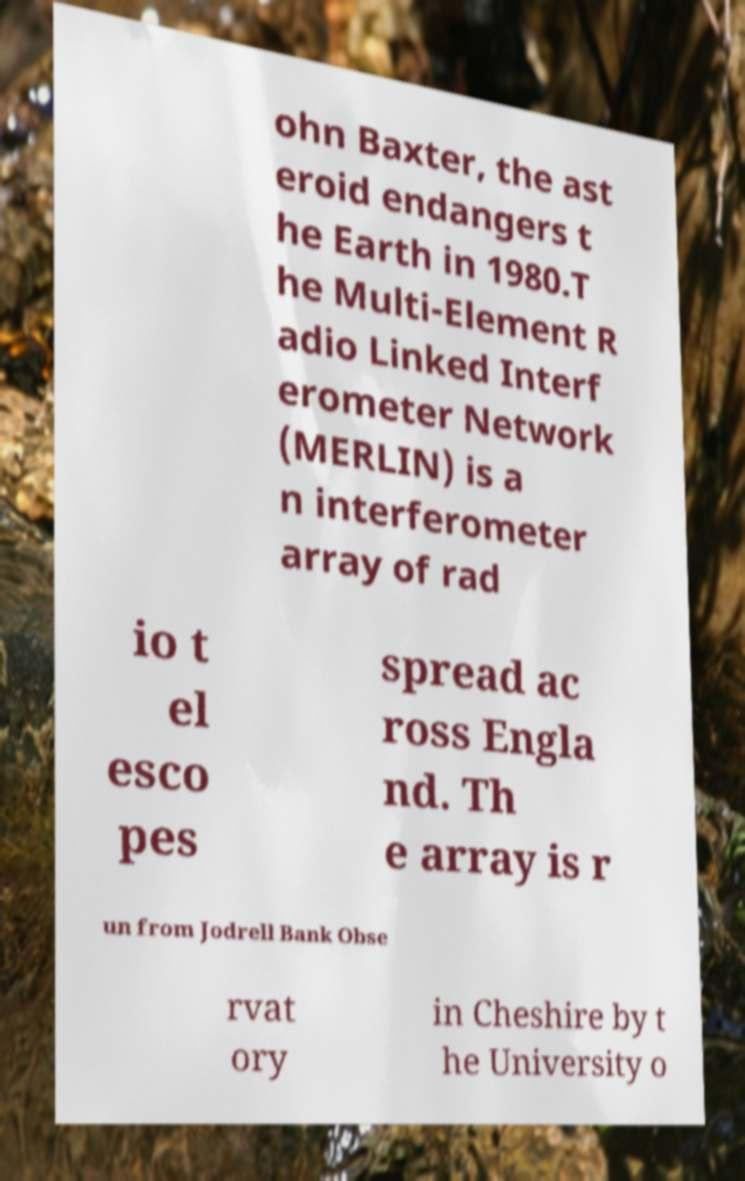Can you read and provide the text displayed in the image?This photo seems to have some interesting text. Can you extract and type it out for me? ohn Baxter, the ast eroid endangers t he Earth in 1980.T he Multi-Element R adio Linked Interf erometer Network (MERLIN) is a n interferometer array of rad io t el esco pes spread ac ross Engla nd. Th e array is r un from Jodrell Bank Obse rvat ory in Cheshire by t he University o 